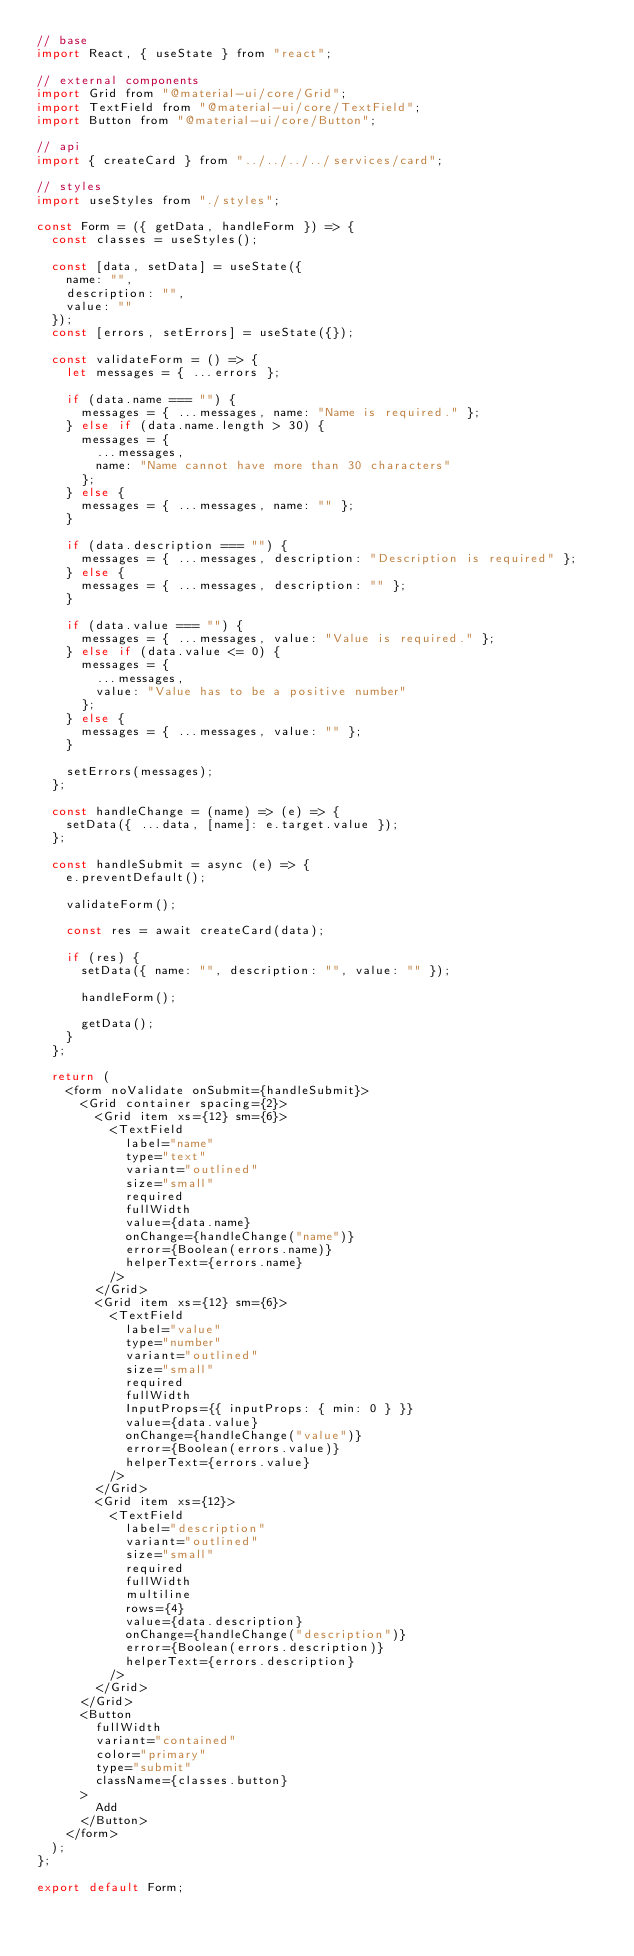Convert code to text. <code><loc_0><loc_0><loc_500><loc_500><_JavaScript_>// base
import React, { useState } from "react";

// external components
import Grid from "@material-ui/core/Grid";
import TextField from "@material-ui/core/TextField";
import Button from "@material-ui/core/Button";

// api
import { createCard } from "../../../../services/card";

// styles
import useStyles from "./styles";

const Form = ({ getData, handleForm }) => {
  const classes = useStyles();

  const [data, setData] = useState({
    name: "",
    description: "",
    value: ""
  });
  const [errors, setErrors] = useState({});

  const validateForm = () => {
    let messages = { ...errors };

    if (data.name === "") {
      messages = { ...messages, name: "Name is required." };
    } else if (data.name.length > 30) {
      messages = {
        ...messages,
        name: "Name cannot have more than 30 characters"
      };
    } else {
      messages = { ...messages, name: "" };
    }

    if (data.description === "") {
      messages = { ...messages, description: "Description is required" };
    } else {
      messages = { ...messages, description: "" };
    }

    if (data.value === "") {
      messages = { ...messages, value: "Value is required." };
    } else if (data.value <= 0) {
      messages = {
        ...messages,
        value: "Value has to be a positive number"
      };
    } else {
      messages = { ...messages, value: "" };
    }

    setErrors(messages);
  };

  const handleChange = (name) => (e) => {
    setData({ ...data, [name]: e.target.value });
  };

  const handleSubmit = async (e) => {
    e.preventDefault();

    validateForm();

    const res = await createCard(data);

    if (res) {
      setData({ name: "", description: "", value: "" });

      handleForm();

      getData();
    }
  };

  return (
    <form noValidate onSubmit={handleSubmit}>
      <Grid container spacing={2}>
        <Grid item xs={12} sm={6}>
          <TextField
            label="name"
            type="text"
            variant="outlined"
            size="small"
            required
            fullWidth
            value={data.name}
            onChange={handleChange("name")}
            error={Boolean(errors.name)}
            helperText={errors.name}
          />
        </Grid>
        <Grid item xs={12} sm={6}>
          <TextField
            label="value"
            type="number"
            variant="outlined"
            size="small"
            required
            fullWidth
            InputProps={{ inputProps: { min: 0 } }}
            value={data.value}
            onChange={handleChange("value")}
            error={Boolean(errors.value)}
            helperText={errors.value}
          />
        </Grid>
        <Grid item xs={12}>
          <TextField
            label="description"
            variant="outlined"
            size="small"
            required
            fullWidth
            multiline
            rows={4}
            value={data.description}
            onChange={handleChange("description")}
            error={Boolean(errors.description)}
            helperText={errors.description}
          />
        </Grid>
      </Grid>
      <Button
        fullWidth
        variant="contained"
        color="primary"
        type="submit"
        className={classes.button}
      >
        Add
      </Button>
    </form>
  );
};

export default Form;
</code> 